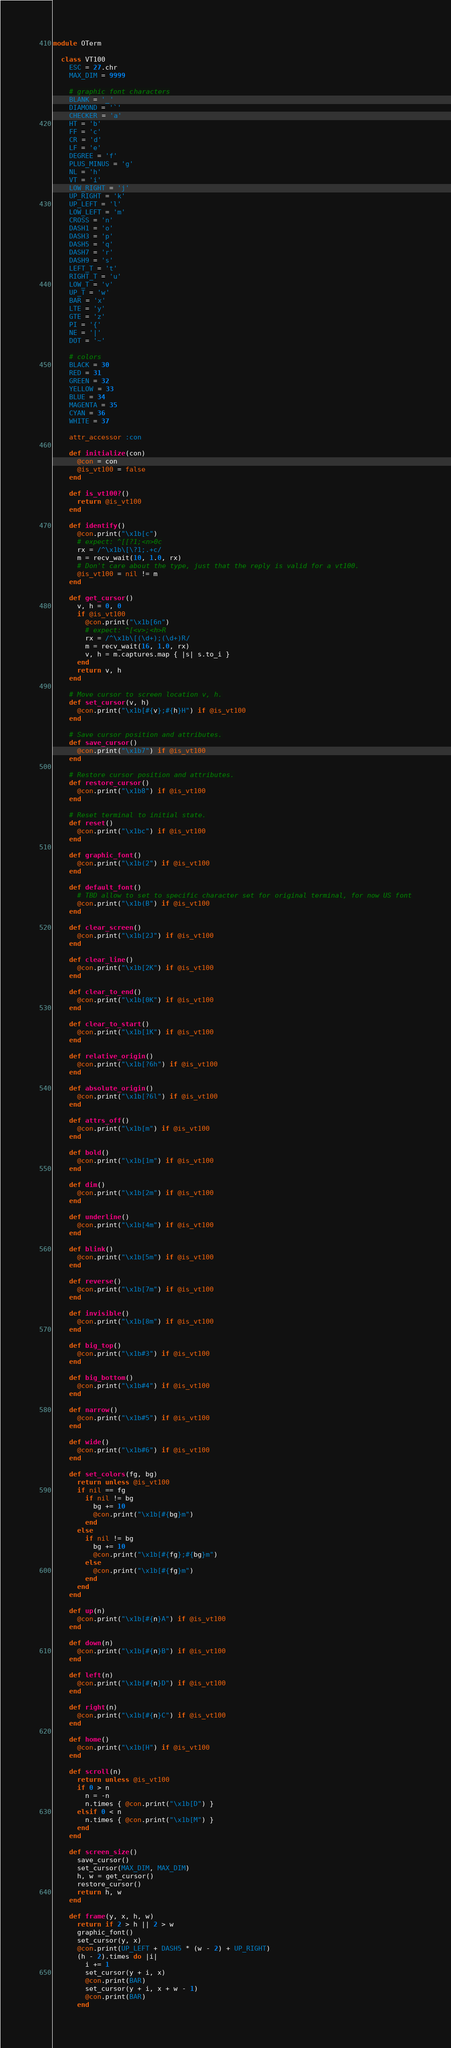<code> <loc_0><loc_0><loc_500><loc_500><_Ruby_>
module OTerm

  class VT100
    ESC = 27.chr
    MAX_DIM = 9999

    # graphic font characters
    BLANK = '_'
    DIAMOND = '`'
    CHECKER = 'a'
    HT = 'b'
    FF = 'c'
    CR = 'd'
    LF = 'e'
    DEGREE = 'f'
    PLUS_MINUS = 'g'
    NL = 'h'
    VT = 'i'
    LOW_RIGHT = 'j'
    UP_RIGHT = 'k'
    UP_LEFT = 'l'
    LOW_LEFT = 'm'
    CROSS = 'n'
    DASH1 = 'o'
    DASH3 = 'p'
    DASH5 = 'q'
    DASH7 = 'r'
    DASH9 = 's'
    LEFT_T = 't'
    RIGHT_T = 'u'
    LOW_T = 'v'
    UP_T = 'w'
    BAR = 'x'
    LTE = 'y'
    GTE = 'z'
    PI = '{'
    NE = '|'
    DOT = '~'

    # colors
    BLACK = 30
    RED = 31
    GREEN = 32
    YELLOW = 33
    BLUE = 34
    MAGENTA = 35
    CYAN = 36
    WHITE = 37

    attr_accessor :con

    def initialize(con)
      @con = con
      @is_vt100 = false
    end

    def is_vt100?()
      return @is_vt100
    end

    def identify()
      @con.print("\x1b[c")
      # expect: ^[[?1;<n>0c
      rx = /^\x1b\[\?1;.+c/
      m = recv_wait(10, 1.0, rx)
      # Don't care about the type, just that the reply is valid for a vt100.
      @is_vt100 = nil != m
    end

    def get_cursor()
      v, h = 0, 0
      if @is_vt100
        @con.print("\x1b[6n")
        # expect: ^[<v>;<h>R
        rx = /^\x1b\[(\d+);(\d+)R/
        m = recv_wait(16, 1.0, rx)
        v, h = m.captures.map { |s| s.to_i }
      end
      return v, h
    end

    # Move cursor to screen location v, h.
    def set_cursor(v, h)
      @con.print("\x1b[#{v};#{h}H") if @is_vt100
    end

    # Save cursor position and attributes.
    def save_cursor()
      @con.print("\x1b7") if @is_vt100
    end

    # Restore cursor position and attributes.
    def restore_cursor()
      @con.print("\x1b8") if @is_vt100
    end

    # Reset terminal to initial state.
    def reset()
      @con.print("\x1bc") if @is_vt100
    end

    def graphic_font()
      @con.print("\x1b(2") if @is_vt100
    end

    def default_font()
      # TBD allow to set to specific character set for original terminal, for now US font
      @con.print("\x1b(B") if @is_vt100
    end

    def clear_screen()
      @con.print("\x1b[2J") if @is_vt100
    end

    def clear_line()
      @con.print("\x1b[2K") if @is_vt100
    end

    def clear_to_end()
      @con.print("\x1b[0K") if @is_vt100
    end

    def clear_to_start()
      @con.print("\x1b[1K") if @is_vt100
    end

    def relative_origin()
      @con.print("\x1b[?6h") if @is_vt100
    end

    def absolute_origin()
      @con.print("\x1b[?6l") if @is_vt100
    end

    def attrs_off()
      @con.print("\x1b[m") if @is_vt100
    end

    def bold()
      @con.print("\x1b[1m") if @is_vt100
    end

    def dim()
      @con.print("\x1b[2m") if @is_vt100
    end

    def underline()
      @con.print("\x1b[4m") if @is_vt100
    end

    def blink()
      @con.print("\x1b[5m") if @is_vt100
    end

    def reverse()
      @con.print("\x1b[7m") if @is_vt100
    end

    def invisible()
      @con.print("\x1b[8m") if @is_vt100
    end

    def big_top()
      @con.print("\x1b#3") if @is_vt100
    end

    def big_bottom()
      @con.print("\x1b#4") if @is_vt100
    end

    def narrow()
      @con.print("\x1b#5") if @is_vt100
    end

    def wide()
      @con.print("\x1b#6") if @is_vt100
    end

    def set_colors(fg, bg)
      return unless @is_vt100
      if nil == fg
        if nil != bg
          bg += 10
          @con.print("\x1b[#{bg}m")
        end
      else
        if nil != bg
          bg += 10
          @con.print("\x1b[#{fg};#{bg}m")
        else
          @con.print("\x1b[#{fg}m")
        end
      end
    end

    def up(n)
      @con.print("\x1b[#{n}A") if @is_vt100
    end

    def down(n)
      @con.print("\x1b[#{n}B") if @is_vt100
    end

    def left(n)
      @con.print("\x1b[#{n}D") if @is_vt100
    end

    def right(n)
      @con.print("\x1b[#{n}C") if @is_vt100
    end

    def home()
      @con.print("\x1b[H") if @is_vt100
    end

    def scroll(n)
      return unless @is_vt100
      if 0 > n
        n = -n
        n.times { @con.print("\x1b[D") }
      elsif 0 < n
        n.times { @con.print("\x1b[M") }
      end
    end

    def screen_size()
      save_cursor()
      set_cursor(MAX_DIM, MAX_DIM)
      h, w = get_cursor()
      restore_cursor()
      return h, w
    end

    def frame(y, x, h, w)
      return if 2 > h || 2 > w
      graphic_font()
      set_cursor(y, x)
      @con.print(UP_LEFT + DASH5 * (w - 2) + UP_RIGHT)
      (h - 2).times do |i|
        i += 1
        set_cursor(y + i, x)
        @con.print(BAR)
        set_cursor(y + i, x + w - 1)
        @con.print(BAR)
      end</code> 